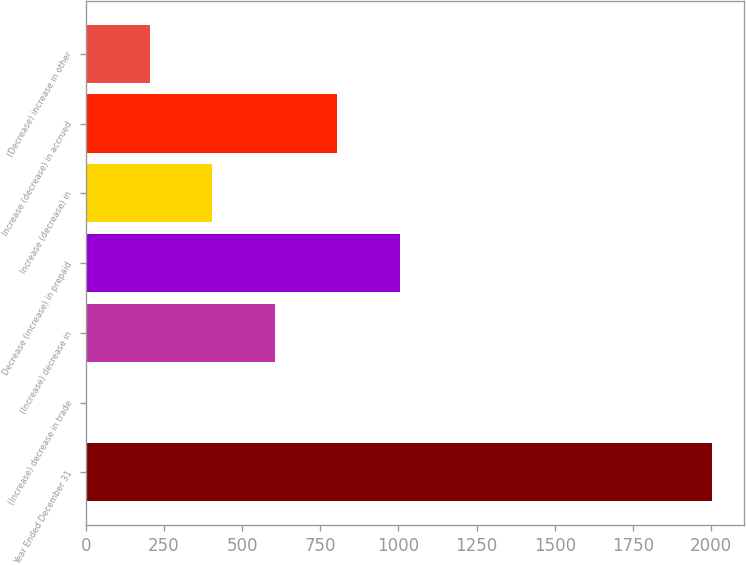Convert chart. <chart><loc_0><loc_0><loc_500><loc_500><bar_chart><fcel>Year Ended December 31<fcel>(Increase) decrease in trade<fcel>(Increase) decrease in<fcel>Decrease (increase) in prepaid<fcel>Increase (decrease) in<fcel>Increase (decrease) in accrued<fcel>(Decrease) increase in other<nl><fcel>2004<fcel>5<fcel>604.7<fcel>1004.5<fcel>404.8<fcel>804.6<fcel>204.9<nl></chart> 